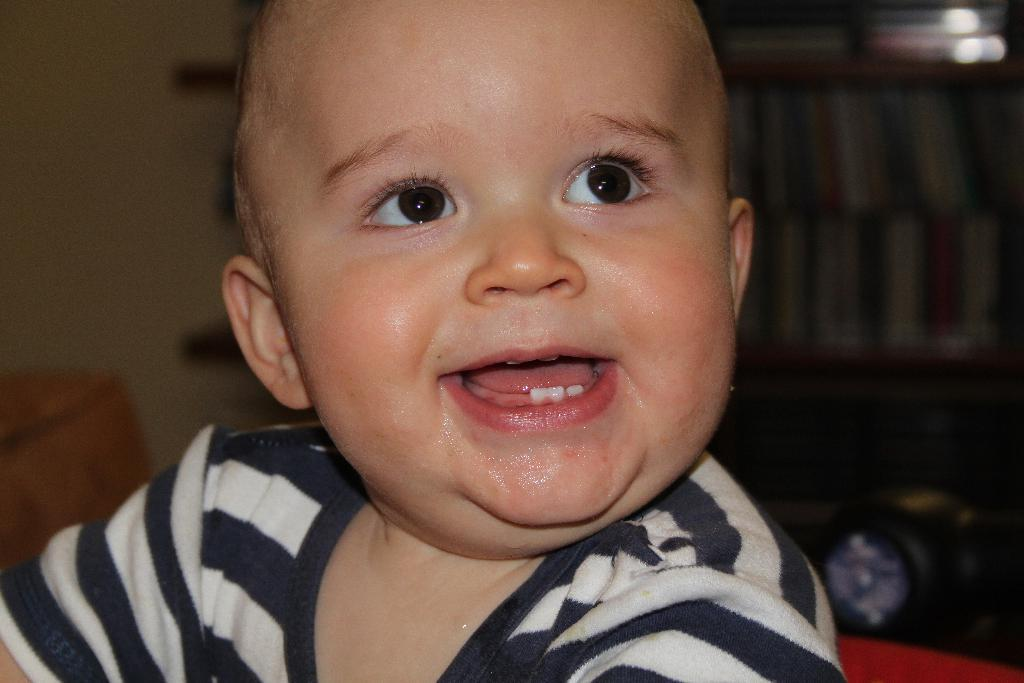Who or what is the main subject of the image? There is a person in the image. What is the person wearing? The person is wearing a black and white shirt. What can be seen in the background of the image? There are books in a rack in the background of the image. What color is the wall in the image? The wall is in cream color. What type of umbrella is the person holding in the image? There is no umbrella present in the image. Can you tell me how many faucets are visible in the image? There are no faucets visible in the image. 